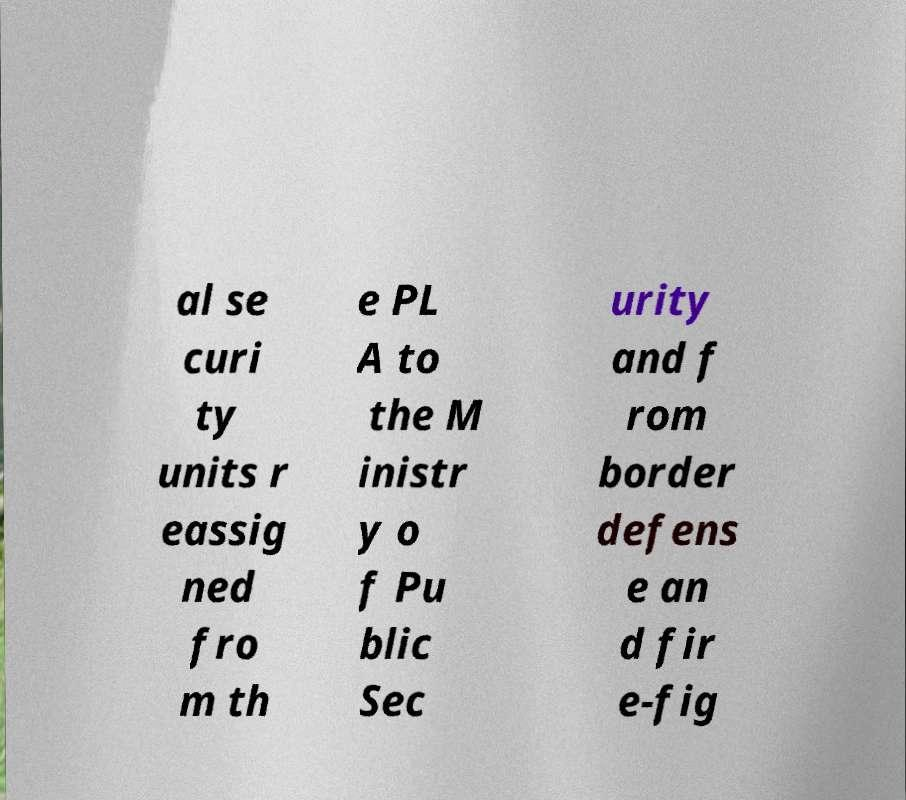Can you read and provide the text displayed in the image?This photo seems to have some interesting text. Can you extract and type it out for me? al se curi ty units r eassig ned fro m th e PL A to the M inistr y o f Pu blic Sec urity and f rom border defens e an d fir e-fig 